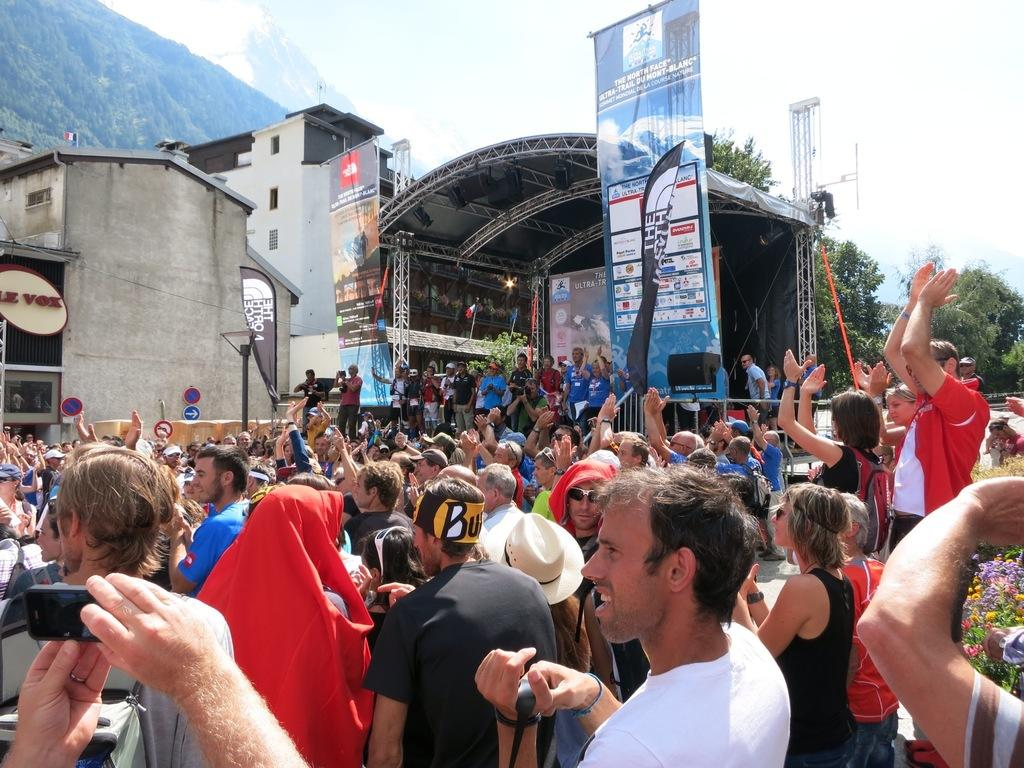What can be seen in the image involving people? There are people standing in the image. What type of structures are visible in the image? There are buildings in the image. What is the purpose of the screen under a roof in the image? The purpose of the screen under a roof is not specified, but it could be a display or information board. What type of vegetation is present in the image? Trees are present in the image. What type of vertical structures can be seen in the image? There are poles in the image. What type of natural landform is visible in the image? There is a hill visible in the image. How does the beggar interact with the people in the image? There is no beggar present in the image. What type of branch is hanging from the trees in the image? There are no branches hanging from the trees in the image; only trees are mentioned. 